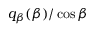<formula> <loc_0><loc_0><loc_500><loc_500>q _ { \beta } ( \beta ) / \cos \beta</formula> 